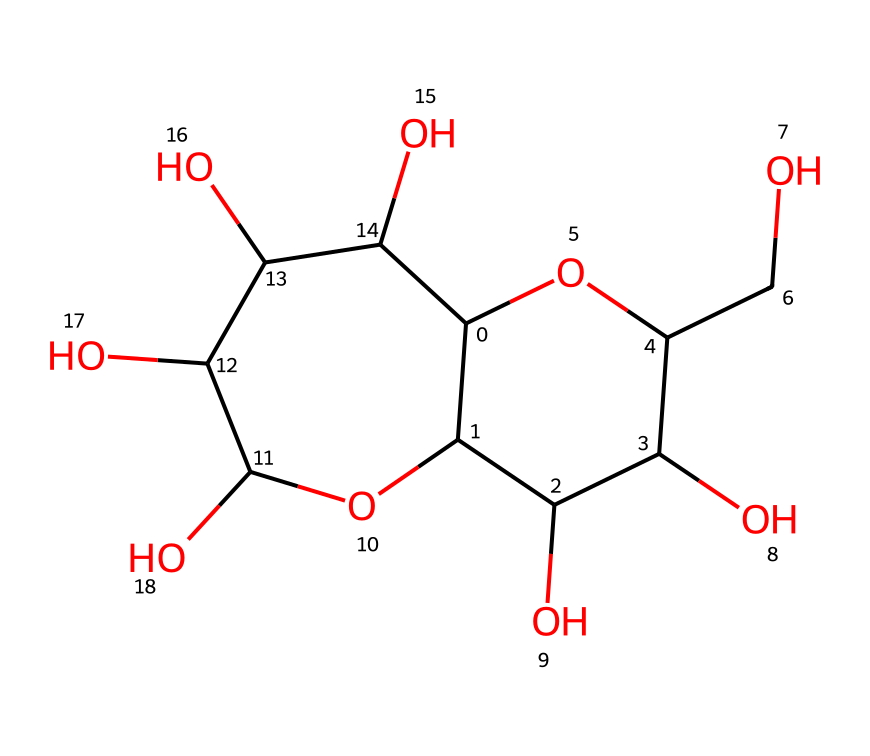how many carbon atoms are in the chemical? By analyzing the provided SMILES structure, we can identify the number of carbon atoms. Each 'C' in the SMILES represents a carbon atom. Counting all the 'C' in the structure gives us a total of 12 carbon atoms.
Answer: 12 how many hydroxyl (OH) groups are present? In the chemical structure, hydroxyl (OH) groups are indicated by -OH attachments to carbon atoms. By examining the structure, we can identify that there are 6 such OH groups present.
Answer: 6 what is the general classification of this chemical? The structure represents a molecule related to sugars, specifically a polyol given its multiple hydroxyl groups. The presence of many carbon and hydroxyl groups leads to its classification as a carbohydrate.
Answer: carbohydrate which functional groups are present in this chemical? Upon examining the structure closely, the two primary functional groups present are hydroxyl (-OH) groups and ether linkages represented by the connections between carbon atoms. This combination characterizes it further as a type of sugar.
Answer: hydroxyl and ether what type of taste could this syrup provide? The presence of multiple hydroxyl groups and the characteristic structure of carbohydrates suggests that this syrup would likely provide a sweet taste, ideal for café-style flavored syrups.
Answer: sweet are there any rings in the structure? By observing the molecular structure represented in the SMILES, we can identify that it contains two fused rings, which are characteristic of cyclic compounds. This can be confirmed by the notation of the numbers in the SMILES that indicate ring closures.
Answer: yes 